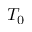Convert formula to latex. <formula><loc_0><loc_0><loc_500><loc_500>T _ { 0 }</formula> 